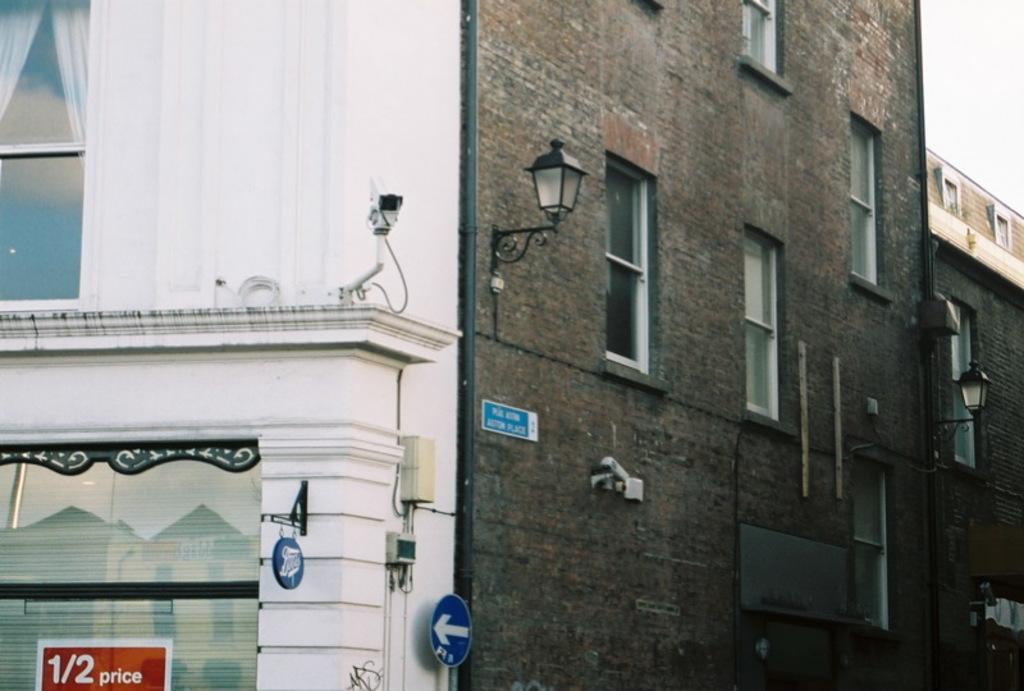Describe this image in one or two sentences. In this picture we can see buildings, we can see windows of these buildings, there are two boards at the bottom, we can see two lights and a camera in the middle, on the left side there is a glass window, there is the sky at the right top of the picture, we can see a pipe in the middle. 